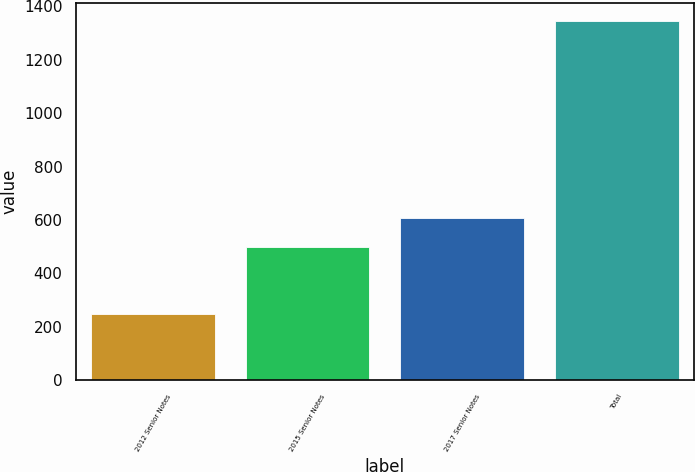Convert chart. <chart><loc_0><loc_0><loc_500><loc_500><bar_chart><fcel>2012 Senior Notes<fcel>2015 Senior Notes<fcel>2017 Senior Notes<fcel>Total<nl><fcel>250<fcel>498<fcel>607.6<fcel>1346<nl></chart> 